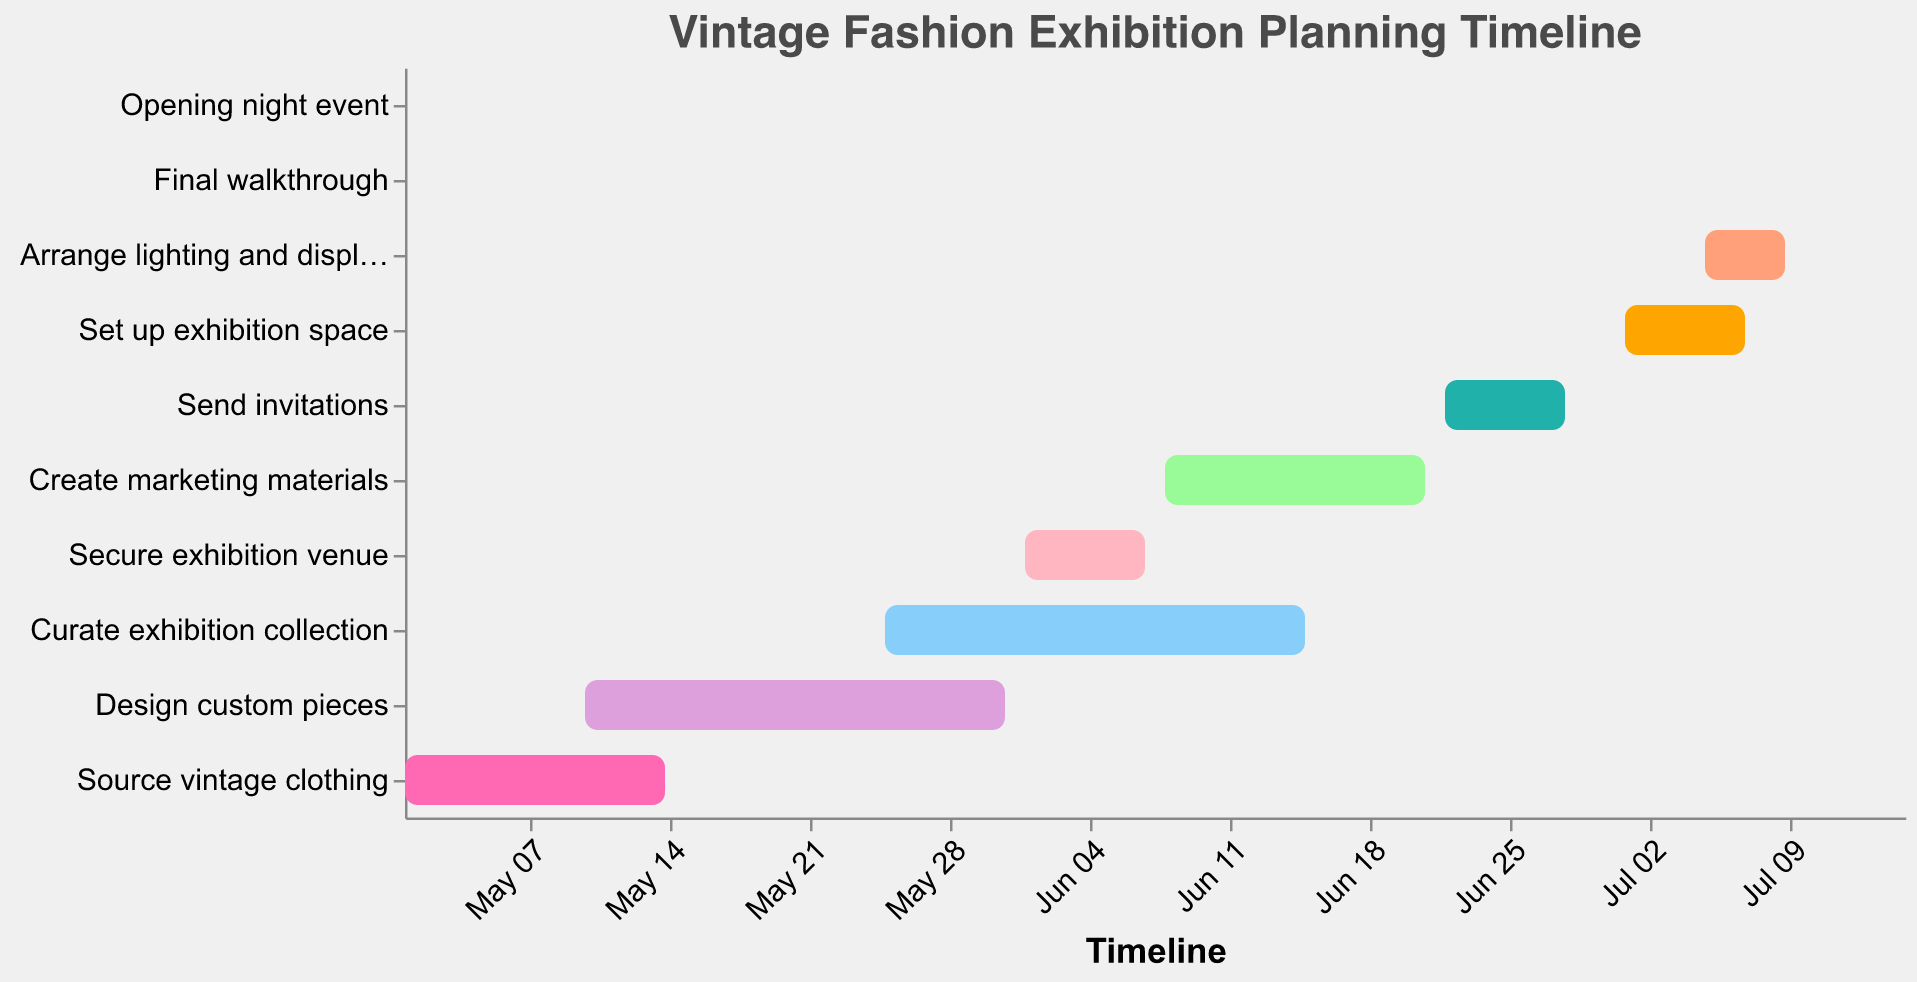What is the title of this Gantt chart? The title of the Gantt chart is usually displayed at the top of the figure.
Answer: Vintage Fashion Exhibition Planning Timeline How many tasks are listed in the Gantt chart? Count the number of distinct bars or tasks listed along the y-axis of the Gantt chart.
Answer: 10 Which task spans the longest period? Compare the start and end dates for each task to determine which one extends over the longest duration.
Answer: Designing custom pieces What is the start date for sending invitations? Locate the bar labeled "Send invitations" and check its starting point on the x-axis.
Answer: June 22, 2023 Which tasks overlap in early June? Examine the tasks and their timelines around early June to identify those occurring at the same time.
Answer: Secure exhibition venue, Curate exhibition collection When should the final walkthrough be completed? Look at the bar labeled "Final walkthrough" and note its start and end date.
Answer: July 10, 2023 How many days are allocated for setting up the exhibition space? Check the start and end dates of "Set up exhibition space," then calculate the number of days between these dates.
Answer: 7 days Which two tasks have overlapping periods in early July? Observe the tasks and find those whose timelines coincide in early July.
Answer: Set up exhibition space, Arrange lighting and displays What is the duration between securing the exhibition venue and creating marketing materials? Find the end date of "Secure exhibition venue" and the start date of "Create marketing materials," then calculate the days between them.
Answer: 1 day (June 7 to June 8) What task is scheduled right before the opening night event? Identify the task that ends just before the "Opening night event" on the timeline.
Answer: Final walkthrough 